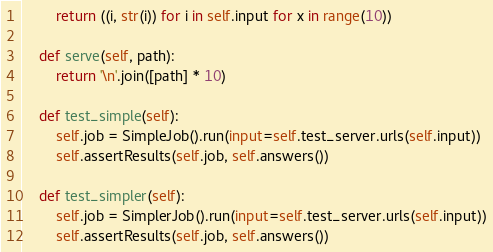Convert code to text. <code><loc_0><loc_0><loc_500><loc_500><_Python_>        return ((i, str(i)) for i in self.input for x in range(10))

    def serve(self, path):
        return '\n'.join([path] * 10)

    def test_simple(self):
        self.job = SimpleJob().run(input=self.test_server.urls(self.input))
        self.assertResults(self.job, self.answers())

    def test_simpler(self):
        self.job = SimplerJob().run(input=self.test_server.urls(self.input))
        self.assertResults(self.job, self.answers())
</code> 